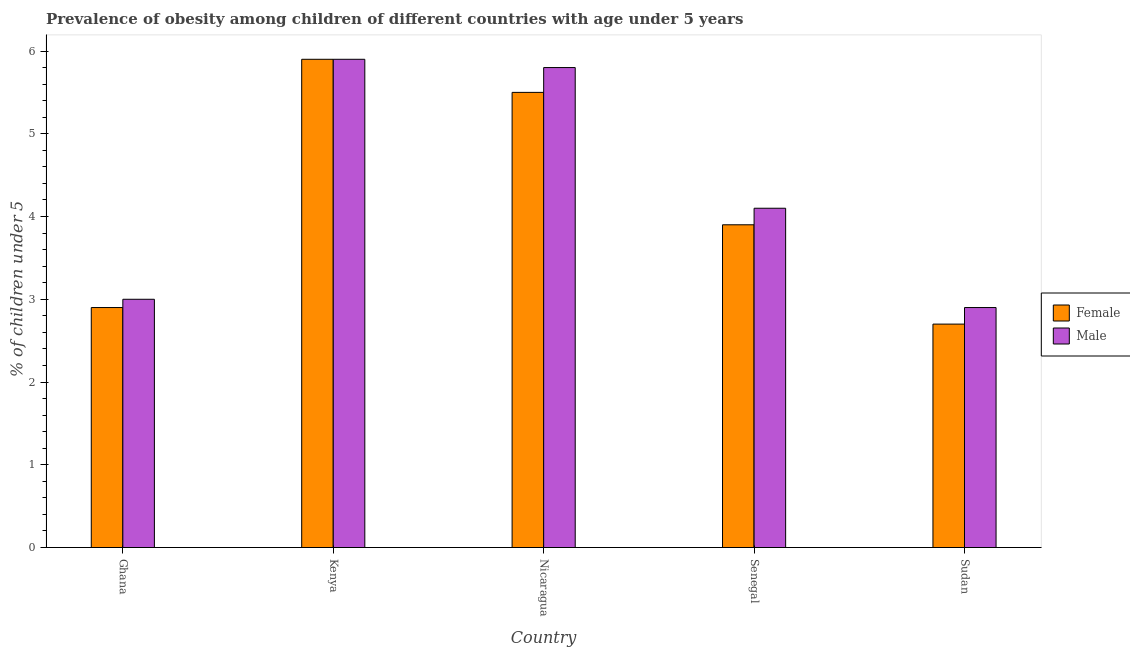How many different coloured bars are there?
Keep it short and to the point. 2. How many groups of bars are there?
Your answer should be compact. 5. Are the number of bars on each tick of the X-axis equal?
Your response must be concise. Yes. How many bars are there on the 2nd tick from the left?
Provide a short and direct response. 2. What is the label of the 4th group of bars from the left?
Your answer should be compact. Senegal. What is the percentage of obese female children in Senegal?
Offer a very short reply. 3.9. Across all countries, what is the maximum percentage of obese female children?
Make the answer very short. 5.9. Across all countries, what is the minimum percentage of obese female children?
Ensure brevity in your answer.  2.7. In which country was the percentage of obese female children maximum?
Your response must be concise. Kenya. In which country was the percentage of obese male children minimum?
Provide a short and direct response. Sudan. What is the total percentage of obese female children in the graph?
Give a very brief answer. 20.9. What is the difference between the percentage of obese male children in Kenya and that in Senegal?
Offer a very short reply. 1.8. What is the difference between the percentage of obese female children in Senegal and the percentage of obese male children in Ghana?
Give a very brief answer. 0.9. What is the average percentage of obese male children per country?
Your response must be concise. 4.34. What is the difference between the percentage of obese female children and percentage of obese male children in Sudan?
Your response must be concise. -0.2. In how many countries, is the percentage of obese male children greater than 2 %?
Offer a very short reply. 5. What is the ratio of the percentage of obese male children in Nicaragua to that in Senegal?
Give a very brief answer. 1.41. Is the percentage of obese male children in Kenya less than that in Senegal?
Make the answer very short. No. What is the difference between the highest and the second highest percentage of obese male children?
Your response must be concise. 0.1. What is the difference between the highest and the lowest percentage of obese female children?
Your answer should be very brief. 3.2. Is the sum of the percentage of obese male children in Nicaragua and Sudan greater than the maximum percentage of obese female children across all countries?
Provide a succinct answer. Yes. What does the 2nd bar from the left in Sudan represents?
Provide a short and direct response. Male. What does the 2nd bar from the right in Sudan represents?
Offer a terse response. Female. How many bars are there?
Your answer should be very brief. 10. Are all the bars in the graph horizontal?
Make the answer very short. No. How many countries are there in the graph?
Give a very brief answer. 5. What is the difference between two consecutive major ticks on the Y-axis?
Keep it short and to the point. 1. Does the graph contain any zero values?
Provide a short and direct response. No. Where does the legend appear in the graph?
Provide a succinct answer. Center right. How many legend labels are there?
Offer a terse response. 2. What is the title of the graph?
Offer a very short reply. Prevalence of obesity among children of different countries with age under 5 years. What is the label or title of the X-axis?
Offer a terse response. Country. What is the label or title of the Y-axis?
Give a very brief answer.  % of children under 5. What is the  % of children under 5 of Female in Ghana?
Provide a succinct answer. 2.9. What is the  % of children under 5 in Female in Kenya?
Your response must be concise. 5.9. What is the  % of children under 5 in Male in Kenya?
Make the answer very short. 5.9. What is the  % of children under 5 in Female in Nicaragua?
Your answer should be compact. 5.5. What is the  % of children under 5 of Male in Nicaragua?
Ensure brevity in your answer.  5.8. What is the  % of children under 5 of Female in Senegal?
Ensure brevity in your answer.  3.9. What is the  % of children under 5 of Male in Senegal?
Your answer should be very brief. 4.1. What is the  % of children under 5 in Female in Sudan?
Offer a terse response. 2.7. What is the  % of children under 5 in Male in Sudan?
Ensure brevity in your answer.  2.9. Across all countries, what is the maximum  % of children under 5 in Female?
Give a very brief answer. 5.9. Across all countries, what is the maximum  % of children under 5 of Male?
Your answer should be very brief. 5.9. Across all countries, what is the minimum  % of children under 5 of Female?
Offer a terse response. 2.7. Across all countries, what is the minimum  % of children under 5 in Male?
Provide a succinct answer. 2.9. What is the total  % of children under 5 in Female in the graph?
Give a very brief answer. 20.9. What is the total  % of children under 5 in Male in the graph?
Offer a terse response. 21.7. What is the difference between the  % of children under 5 of Male in Ghana and that in Kenya?
Provide a succinct answer. -2.9. What is the difference between the  % of children under 5 of Female in Ghana and that in Sudan?
Your answer should be compact. 0.2. What is the difference between the  % of children under 5 in Female in Kenya and that in Nicaragua?
Ensure brevity in your answer.  0.4. What is the difference between the  % of children under 5 in Male in Kenya and that in Nicaragua?
Provide a succinct answer. 0.1. What is the difference between the  % of children under 5 of Male in Kenya and that in Senegal?
Your answer should be compact. 1.8. What is the difference between the  % of children under 5 in Male in Kenya and that in Sudan?
Your answer should be very brief. 3. What is the difference between the  % of children under 5 in Female in Nicaragua and that in Senegal?
Make the answer very short. 1.6. What is the difference between the  % of children under 5 of Male in Nicaragua and that in Sudan?
Your answer should be compact. 2.9. What is the difference between the  % of children under 5 in Male in Senegal and that in Sudan?
Your response must be concise. 1.2. What is the difference between the  % of children under 5 in Female in Ghana and the  % of children under 5 in Male in Kenya?
Give a very brief answer. -3. What is the difference between the  % of children under 5 in Female in Ghana and the  % of children under 5 in Male in Nicaragua?
Give a very brief answer. -2.9. What is the difference between the  % of children under 5 of Female in Ghana and the  % of children under 5 of Male in Senegal?
Provide a succinct answer. -1.2. What is the difference between the  % of children under 5 of Female in Kenya and the  % of children under 5 of Male in Sudan?
Provide a succinct answer. 3. What is the difference between the  % of children under 5 of Female in Nicaragua and the  % of children under 5 of Male in Senegal?
Your answer should be compact. 1.4. What is the difference between the  % of children under 5 in Female in Nicaragua and the  % of children under 5 in Male in Sudan?
Your response must be concise. 2.6. What is the difference between the  % of children under 5 of Female in Senegal and the  % of children under 5 of Male in Sudan?
Your answer should be very brief. 1. What is the average  % of children under 5 of Female per country?
Give a very brief answer. 4.18. What is the average  % of children under 5 in Male per country?
Make the answer very short. 4.34. What is the difference between the  % of children under 5 in Female and  % of children under 5 in Male in Ghana?
Ensure brevity in your answer.  -0.1. What is the difference between the  % of children under 5 in Female and  % of children under 5 in Male in Kenya?
Provide a succinct answer. 0. What is the difference between the  % of children under 5 of Female and  % of children under 5 of Male in Nicaragua?
Keep it short and to the point. -0.3. What is the difference between the  % of children under 5 of Female and  % of children under 5 of Male in Sudan?
Your answer should be compact. -0.2. What is the ratio of the  % of children under 5 of Female in Ghana to that in Kenya?
Your response must be concise. 0.49. What is the ratio of the  % of children under 5 of Male in Ghana to that in Kenya?
Give a very brief answer. 0.51. What is the ratio of the  % of children under 5 of Female in Ghana to that in Nicaragua?
Provide a succinct answer. 0.53. What is the ratio of the  % of children under 5 of Male in Ghana to that in Nicaragua?
Make the answer very short. 0.52. What is the ratio of the  % of children under 5 of Female in Ghana to that in Senegal?
Ensure brevity in your answer.  0.74. What is the ratio of the  % of children under 5 of Male in Ghana to that in Senegal?
Give a very brief answer. 0.73. What is the ratio of the  % of children under 5 in Female in Ghana to that in Sudan?
Give a very brief answer. 1.07. What is the ratio of the  % of children under 5 in Male in Ghana to that in Sudan?
Your response must be concise. 1.03. What is the ratio of the  % of children under 5 in Female in Kenya to that in Nicaragua?
Your answer should be very brief. 1.07. What is the ratio of the  % of children under 5 in Male in Kenya to that in Nicaragua?
Your answer should be very brief. 1.02. What is the ratio of the  % of children under 5 of Female in Kenya to that in Senegal?
Provide a short and direct response. 1.51. What is the ratio of the  % of children under 5 of Male in Kenya to that in Senegal?
Give a very brief answer. 1.44. What is the ratio of the  % of children under 5 in Female in Kenya to that in Sudan?
Make the answer very short. 2.19. What is the ratio of the  % of children under 5 in Male in Kenya to that in Sudan?
Your response must be concise. 2.03. What is the ratio of the  % of children under 5 in Female in Nicaragua to that in Senegal?
Offer a very short reply. 1.41. What is the ratio of the  % of children under 5 of Male in Nicaragua to that in Senegal?
Offer a very short reply. 1.41. What is the ratio of the  % of children under 5 of Female in Nicaragua to that in Sudan?
Make the answer very short. 2.04. What is the ratio of the  % of children under 5 of Female in Senegal to that in Sudan?
Provide a succinct answer. 1.44. What is the ratio of the  % of children under 5 of Male in Senegal to that in Sudan?
Provide a succinct answer. 1.41. What is the difference between the highest and the second highest  % of children under 5 of Female?
Make the answer very short. 0.4. What is the difference between the highest and the lowest  % of children under 5 of Female?
Keep it short and to the point. 3.2. What is the difference between the highest and the lowest  % of children under 5 in Male?
Keep it short and to the point. 3. 